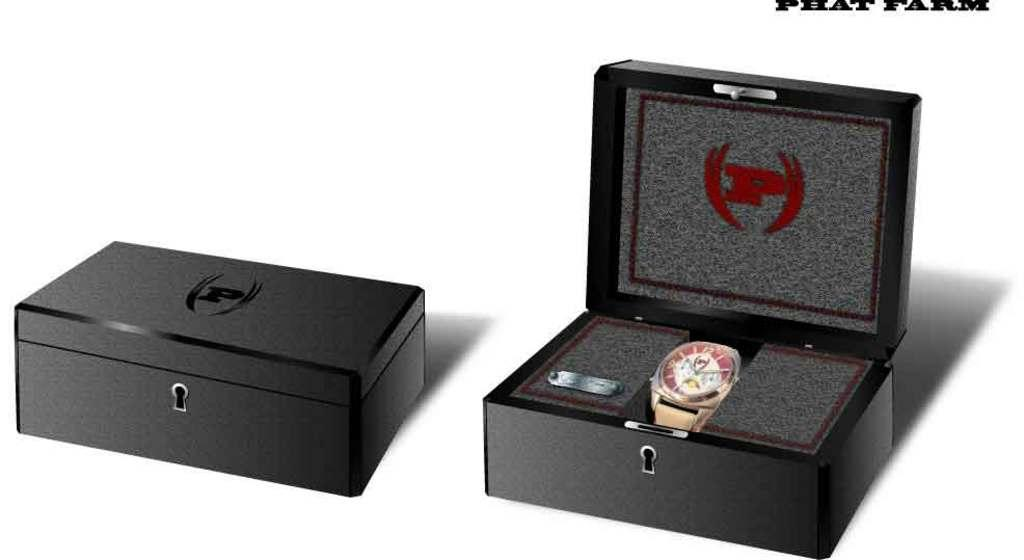<image>
Relay a brief, clear account of the picture shown. Phat Farm watches come in black and gray display boxes. 